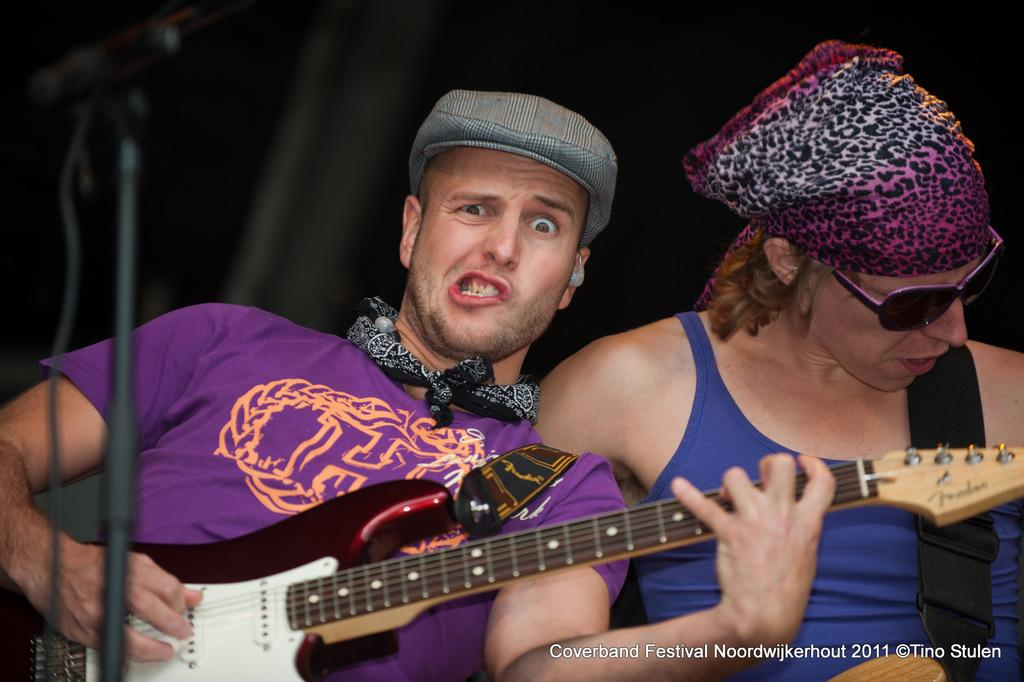How many people are in the image? There are two persons in the image. What is one of the persons doing in the image? One of the persons is playing a guitar. What type of sweater is the army wearing while working on the engine in the image? There is no army, sweater, or engine present in the image. 